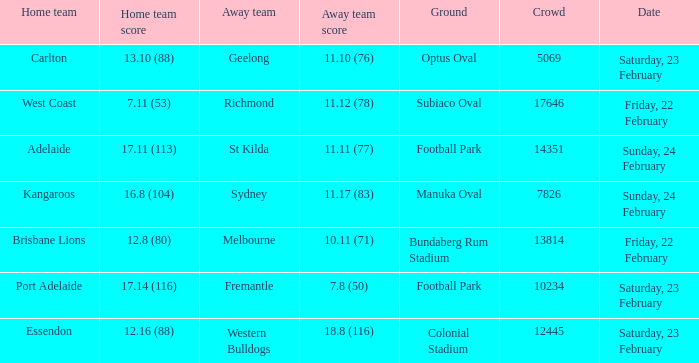On what date did the away team Fremantle play? Saturday, 23 February. 